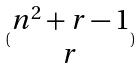Convert formula to latex. <formula><loc_0><loc_0><loc_500><loc_500>( \begin{matrix} n ^ { 2 } + r - 1 \\ r \end{matrix} )</formula> 